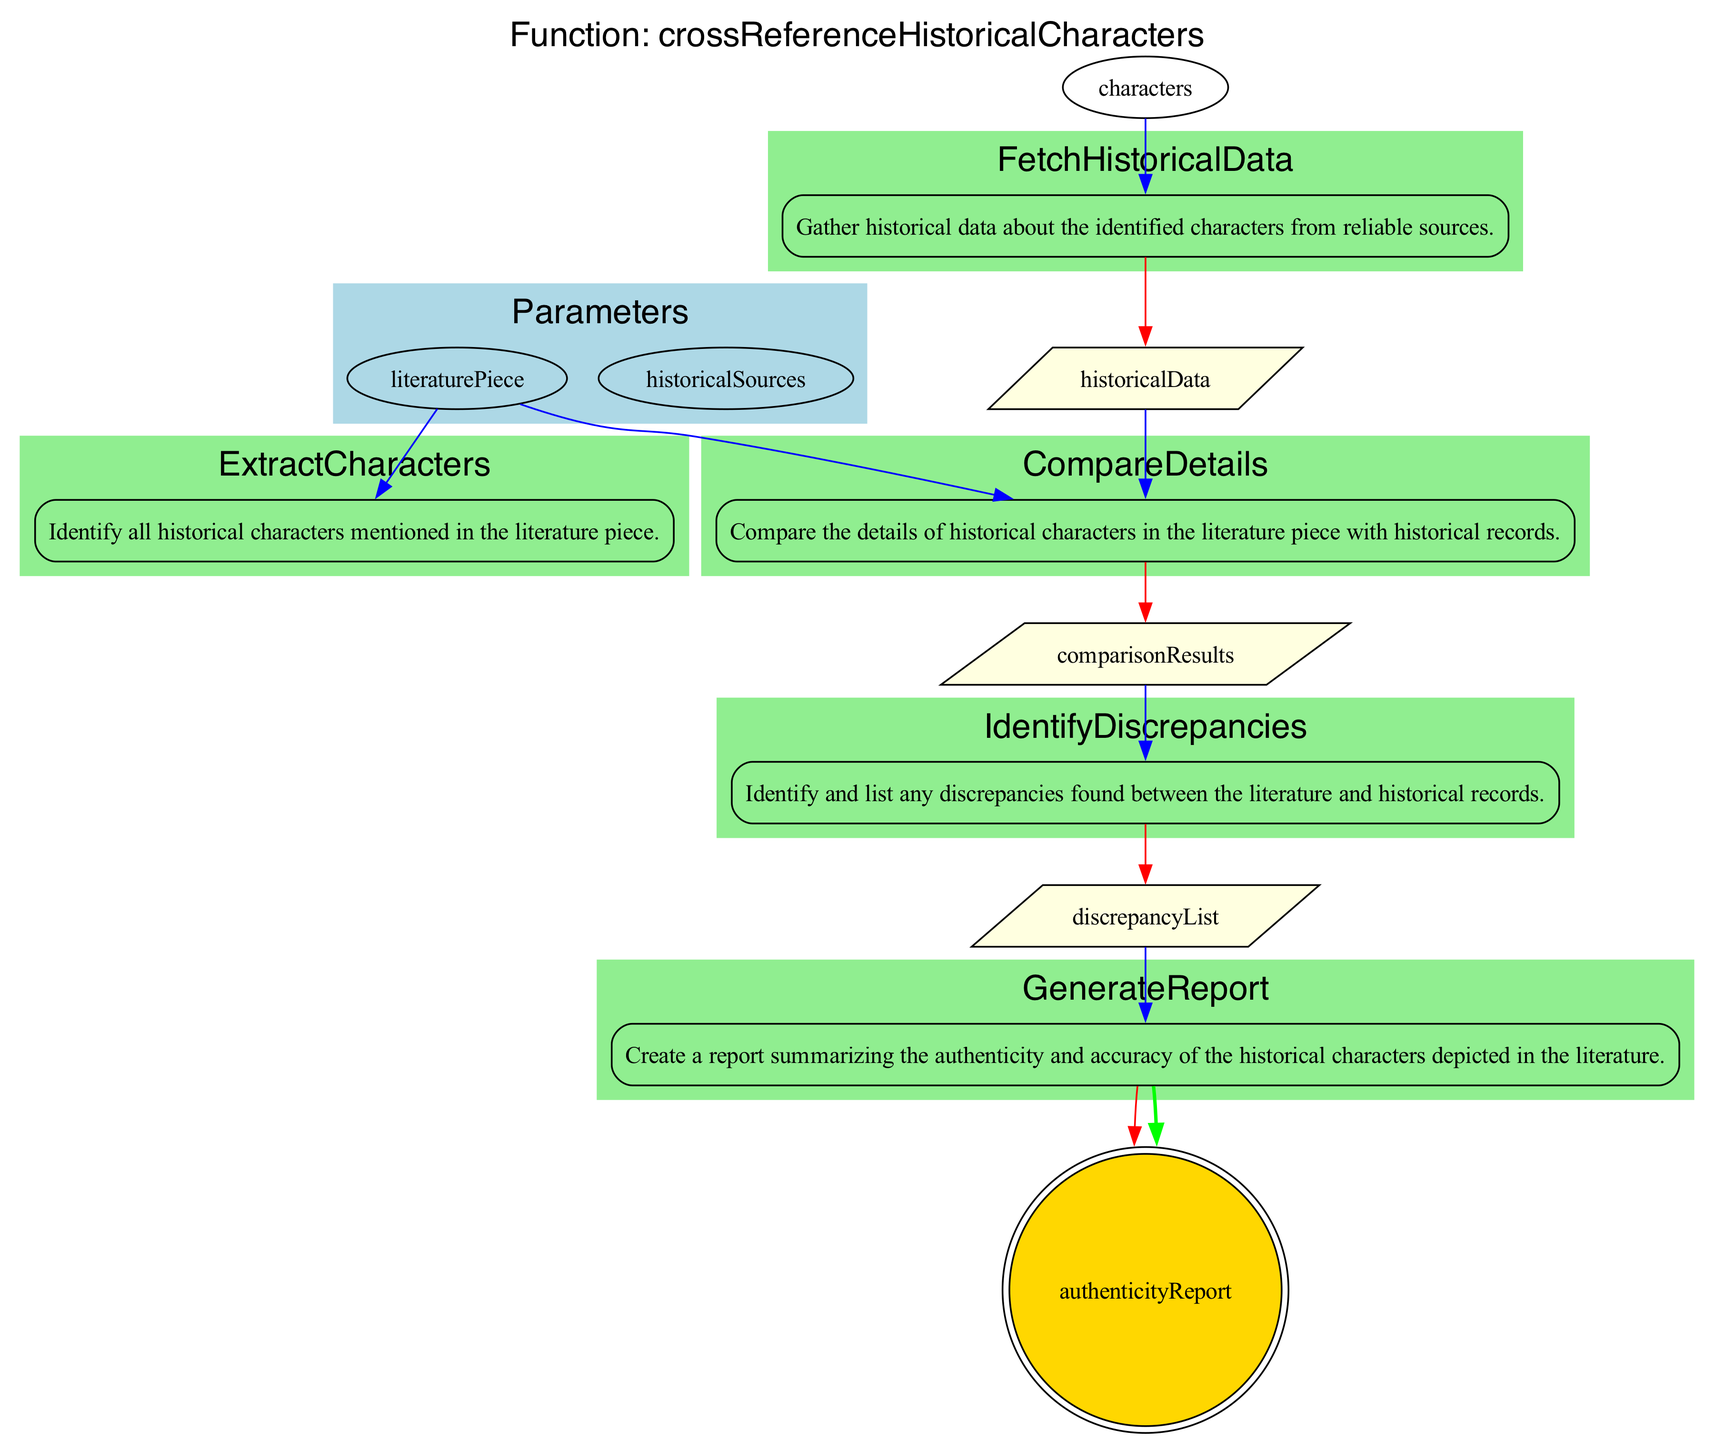What is the function name depicted in the diagram? The function name is clearly displayed at the top of the diagram as "crossReferenceHistoricalCharacters."
Answer: crossReferenceHistoricalCharacters How many steps are there in the function? By counting the number of labeled steps within the flowchart, we can see there are five steps listed sequentially.
Answer: 5 What color is used to represent the steps in the flowchart? The steps are enclosed within subgraphs that are filled with light green to distinguish them from other components.
Answer: light green Which step involves comparing details? The step titled "CompareDetails" is where the comparison of details occurs, as indicated in the flowchart.
Answer: CompareDetails What is the output of the function? The final output is labeled "authenticityReport," which indicates what the function generates after processing.
Answer: authenticityReport How many inputs are there for the "FetchHistoricalData" step? This step has one input, which is the "characters" derived from the previous step in the flowchart.
Answer: 1 Which step leads to identifying discrepancies? The "CompareDetails" step leads directly to the "IdentifyDiscrepancies" step, making it clear how the flow proceeds in this part of the process.
Answer: IdentifyDiscrepancies What type of shape represents the final output? The final output "authenticityReport" is represented as a double circle, which typically signifies an end result or conclusion in flowcharts.
Answer: doublecircle What are the inputs for the "GenerateReport" step? The "GenerateReport" step takes "discrepancyList" as input, which is generated from the prior identification of discrepancies.
Answer: discrepancyList 